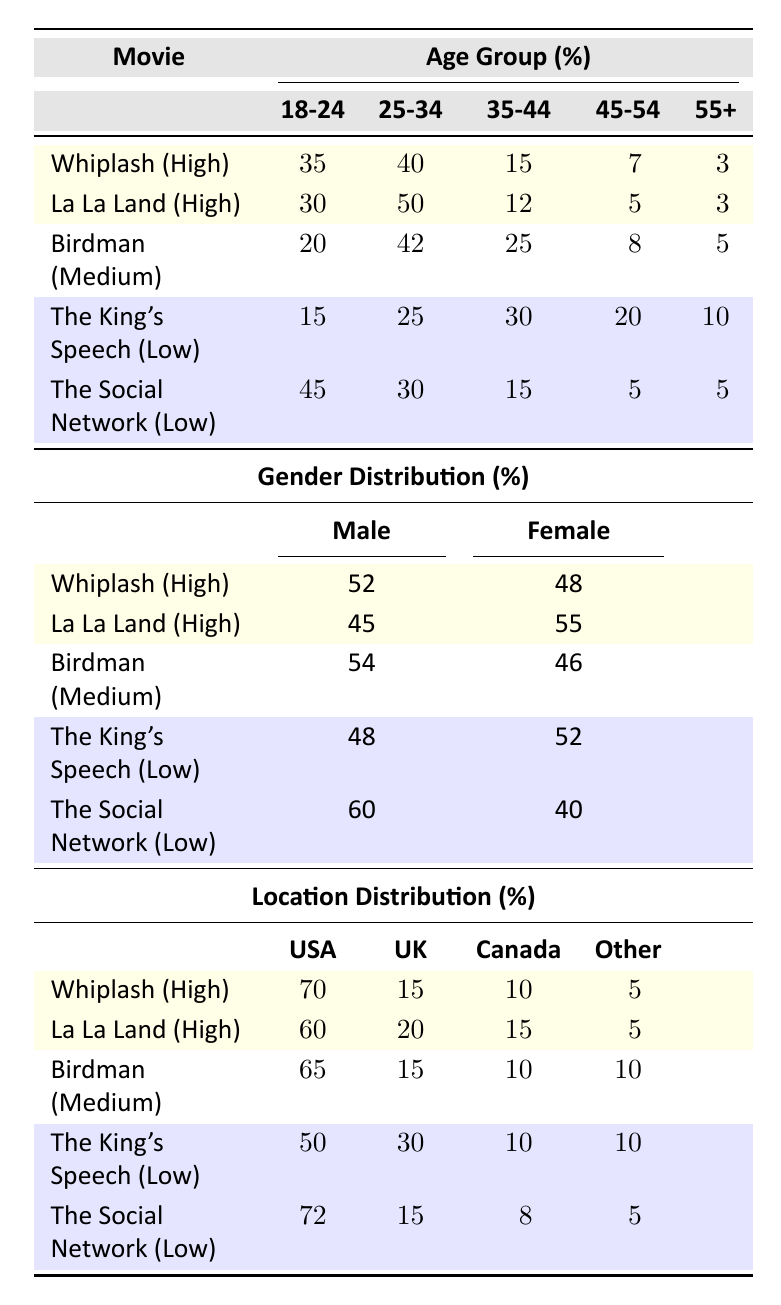What percentage of viewers aged 18-24 watched "The King's Speech"? According to the table, the viewer demographic for "The King's Speech" shows that 15% of its audience is aged 18-24.
Answer: 15% Which movie has the highest percentage of female viewers? The female viewer percentages for the movies are: "Whiplash" 48%, "La La Land" 55%, "Birdman" 46%, "The King's Speech" 52%, and "The Social Network" 40%. "La La Land" has the highest percentage at 55%.
Answer: La La Land What is the average percentage of male viewers across all movies? To find the average percentage of male viewers, add the male percentages: 52 + 45 + 54 + 48 + 60 = 259, then divide by the number of movies (5). So, 259/5 = 51.8%.
Answer: 51.8% Which age group (e.g., 18-24, 25-34) had the lowest percentage of viewers for "Birdman"? The percentages of age groups for "Birdman" are: 18-24: 20%, 25-34: 42%, 35-44: 25%, 45-54: 8%, 55+: 5%. The lowest percentage is for the 55+ age group at 5%.
Answer: 55+ Is "Whiplash" more popular among younger viewers (18-24) or older viewers (45+)? For "Whiplash", 35% of viewers are 18-24, while only 10% (7% aged 45-54 + 3% aged 55+) are 45 or older. Therefore, it is more popular among younger viewers.
Answer: Yes Which movie has the largest percentage of viewers from the USA? The viewer demographics show "The Social Network" has 72% from the USA, which is the largest percentage compared to the other movies.
Answer: The Social Network What is the difference in the percentage of viewers aged 25-34 between "La La Land" and "The King's Speech"? The percentage of viewers aged 25-34 for "La La Land" is 50% and for "The King's Speech" is 25%. The difference is 50% - 25% = 25%.
Answer: 25% Did "Birdman" attract a higher percentage of viewers aged 35-44 compared to "The Social Network"? "Birdman" has 25% of viewers aged 35-44 while "The Social Network" has only 15%. Therefore, "Birdman" attracted a higher percentage.
Answer: Yes What is the total percentage of viewers from Canada for both "The King's Speech" and "Birdman"? "The King's Speech" has 10% from Canada and "Birdman" also has 10% from Canada. So, the total percentage is 10% + 10% = 20%.
Answer: 20% Which gender shows a preference towards "The King's Speech"? For "The King's Speech", the male viewers are 48% and female viewers are 52%, indicating a preference towards female viewers.
Answer: Female 